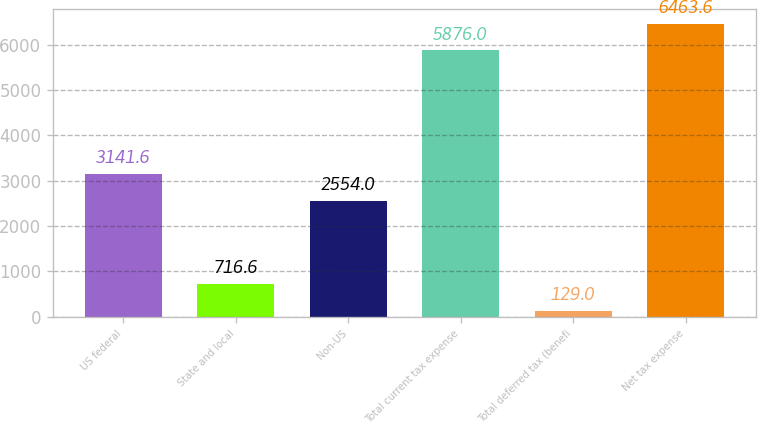<chart> <loc_0><loc_0><loc_500><loc_500><bar_chart><fcel>US federal<fcel>State and local<fcel>Non-US<fcel>Total current tax expense<fcel>Total deferred tax (benefi<fcel>Net tax expense<nl><fcel>3141.6<fcel>716.6<fcel>2554<fcel>5876<fcel>129<fcel>6463.6<nl></chart> 